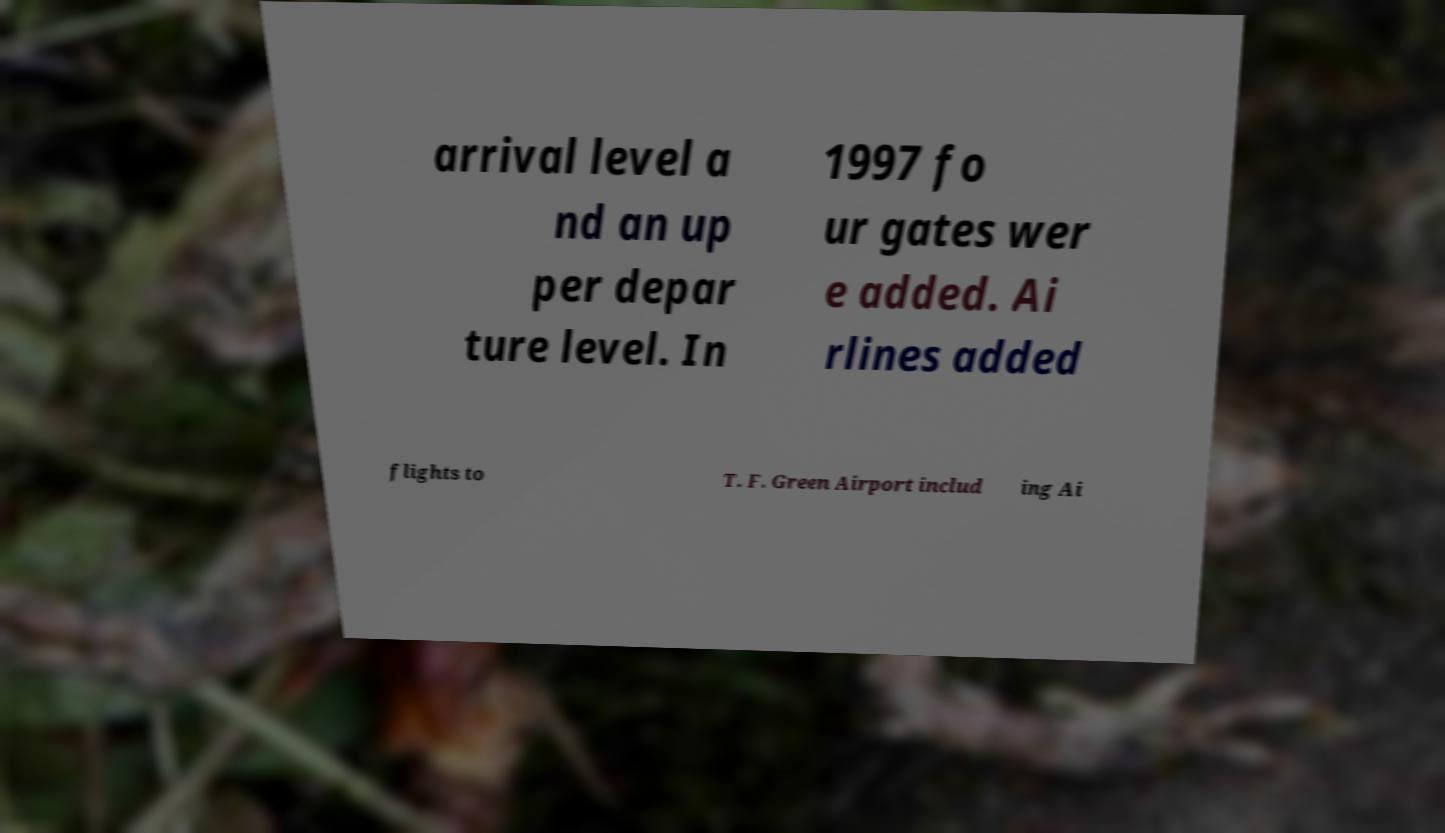I need the written content from this picture converted into text. Can you do that? arrival level a nd an up per depar ture level. In 1997 fo ur gates wer e added. Ai rlines added flights to T. F. Green Airport includ ing Ai 